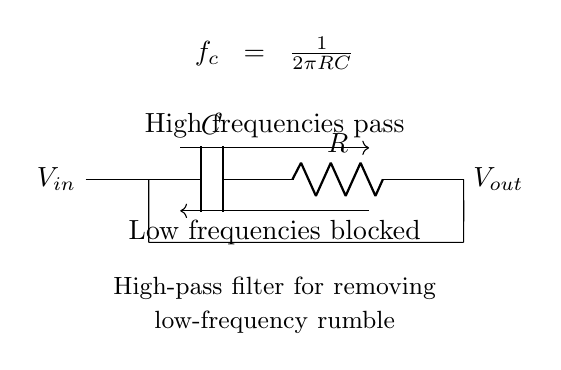What type of filter is represented in this circuit? The circuit diagram clearly shows a high-pass filter design. This is depicted by the arrangement of components (a capacitor and a resistor) which are characteristic of high-pass configurations, as indicated by the labeling.
Answer: high-pass filter What components are used in the circuit? The components used in this circuit are a capacitor (labeled C) and a resistor (labeled R). They are connected in series which defines the filter's behavior.
Answer: capacitor and resistor What does the symbol "V_in" represent in the circuit? The symbol "V_in" indicates the input voltage to the circuit. It is the voltage that is applied to the high-pass filter where low-frequency signal components are to be reduced or blocked.
Answer: input voltage What does the formula "f_c = 1 / (2πRC)" signify? This formula represents the cutoff frequency (f_c) of the high-pass filter. It calculates the frequency at which signals are allowed to pass through while those below this frequency are attenuated. The constants R and C correspond to the resistance and capacitance values in the circuit.
Answer: cutoff frequency What happens to high frequencies according to the diagram? The circuit indicates that high frequencies are allowed to pass through the filter. This is explicitly mentioned with an arrow labeled "High frequencies pass," showing the desired behavior of the circuit.
Answer: allowed to pass What type of signals does this high-pass filter primarily target? This filter primarily targets low-frequency rumble or noise, which it aims to remove by allowing only higher frequency signals to pass through effectively.
Answer: low-frequency rumble At what frequency would signals start to be attenuated? Signals would start to be attenuated at the cutoff frequency (f_c) derived from the formula given in the diagram. This is where the filter begins to block low frequencies.
Answer: cutoff frequency 